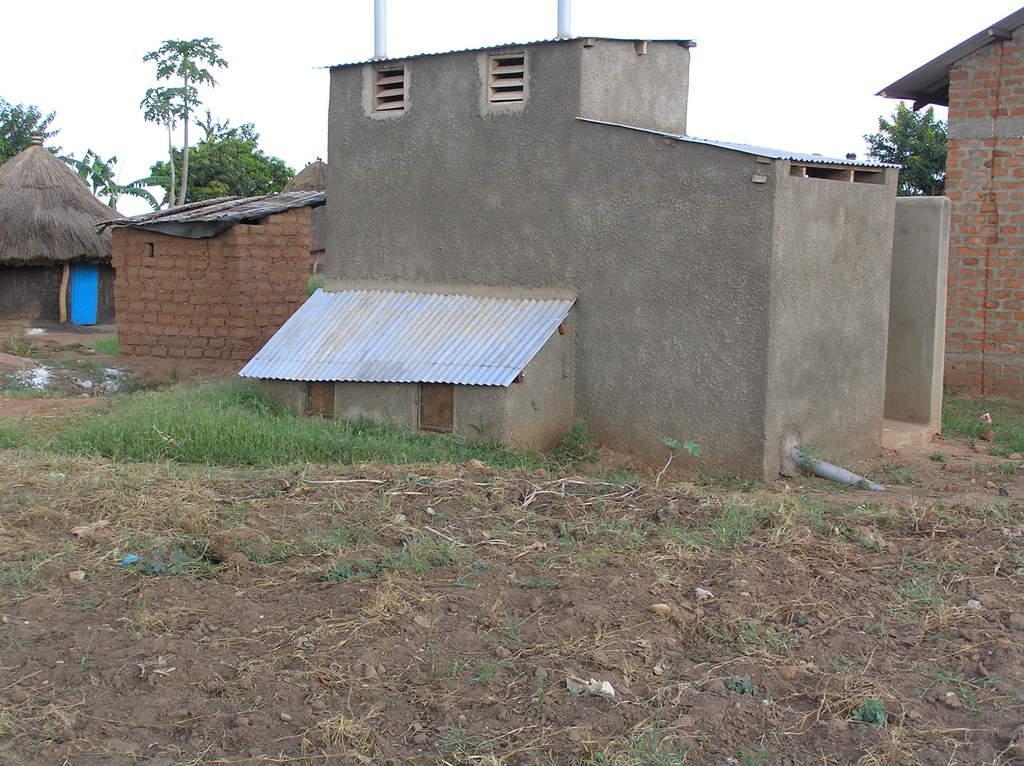In one or two sentences, can you explain what this image depicts? This picture is clicked outside. In the center we can see the buildings and a hut and some green grass. In the background there is a sky and the trees. 